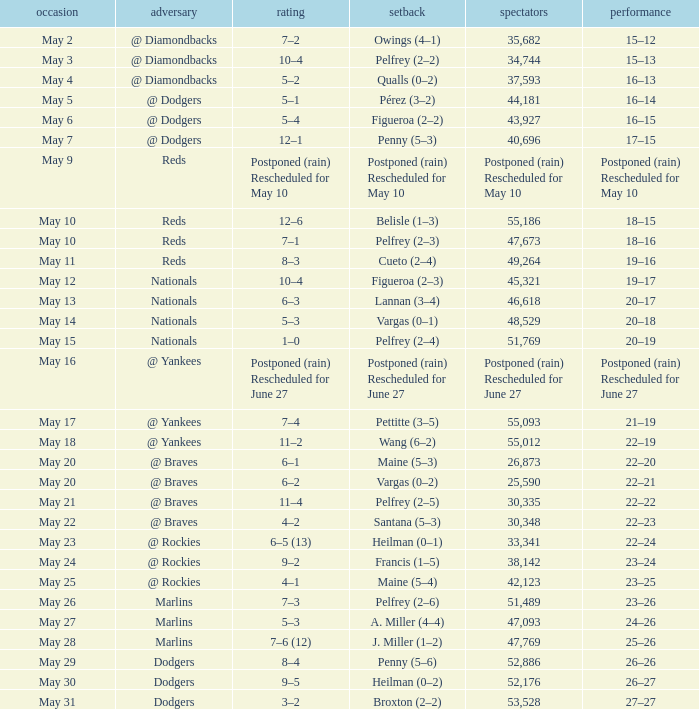Regarding the loss postponed (due to rain) and rescheduled for may 10, what was the record? Postponed (rain) Rescheduled for May 10. 